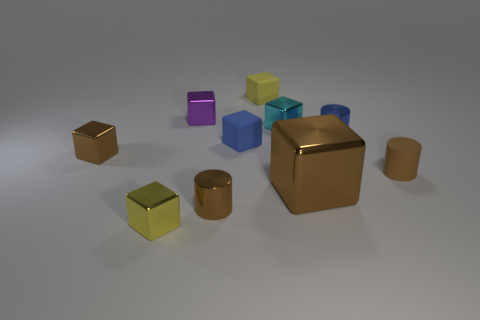Subtract all shiny cylinders. How many cylinders are left? 1 Subtract all blue cylinders. How many cylinders are left? 2 Subtract all cylinders. How many objects are left? 7 Subtract 4 blocks. How many blocks are left? 3 Subtract all red cubes. Subtract all brown cylinders. How many cubes are left? 7 Subtract all purple cylinders. How many yellow cubes are left? 2 Subtract all big yellow shiny cubes. Subtract all brown cubes. How many objects are left? 8 Add 6 small blue metallic things. How many small blue metallic things are left? 7 Add 9 small yellow metal things. How many small yellow metal things exist? 10 Subtract 0 purple spheres. How many objects are left? 10 